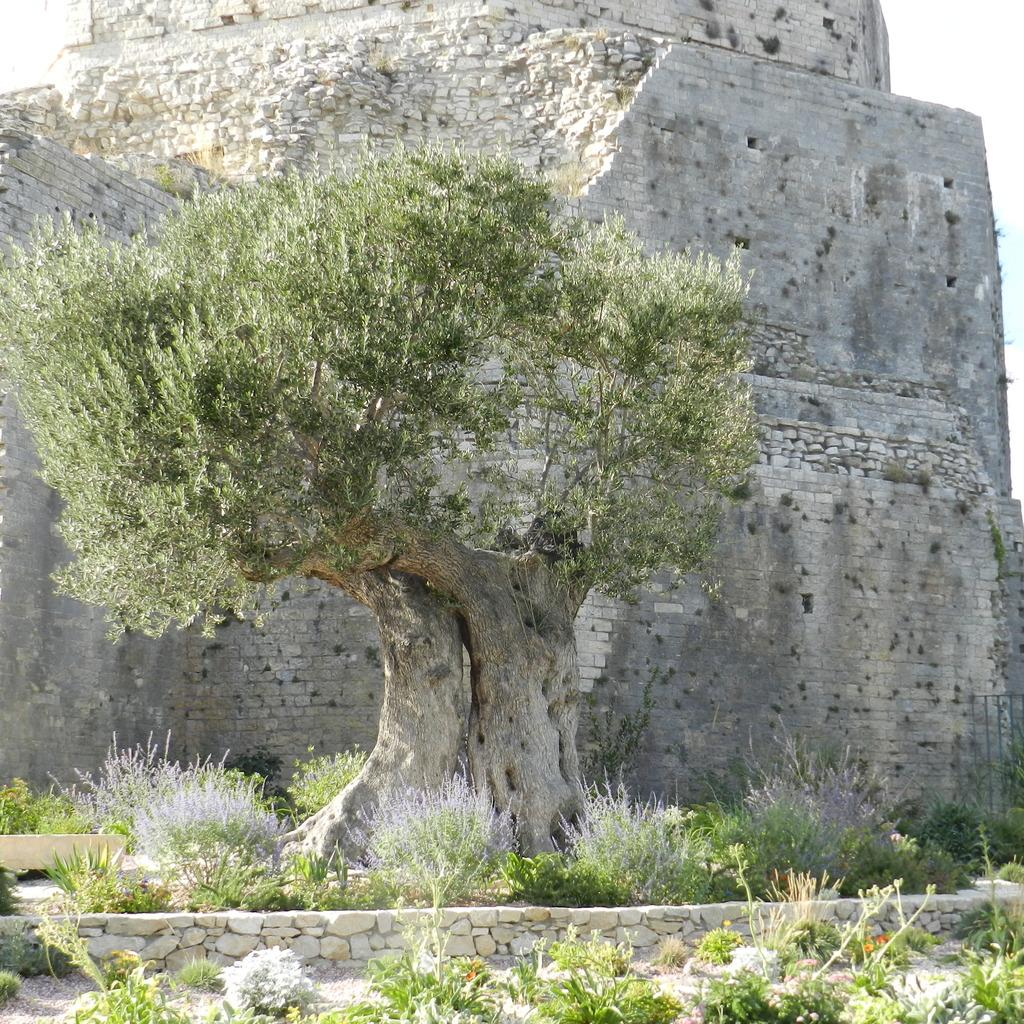What is the main subject in the center of the image? There is a tree in the center of the image. What can be seen in the background of the image? There is a fort visible in the background, and the sky is also visible. What type of vegetation is present at the bottom of the image? There is grass and plants at the bottom of the image. What brand of toothpaste is advertised on the tree in the image? There is no toothpaste or advertisement present on the tree in the image. 